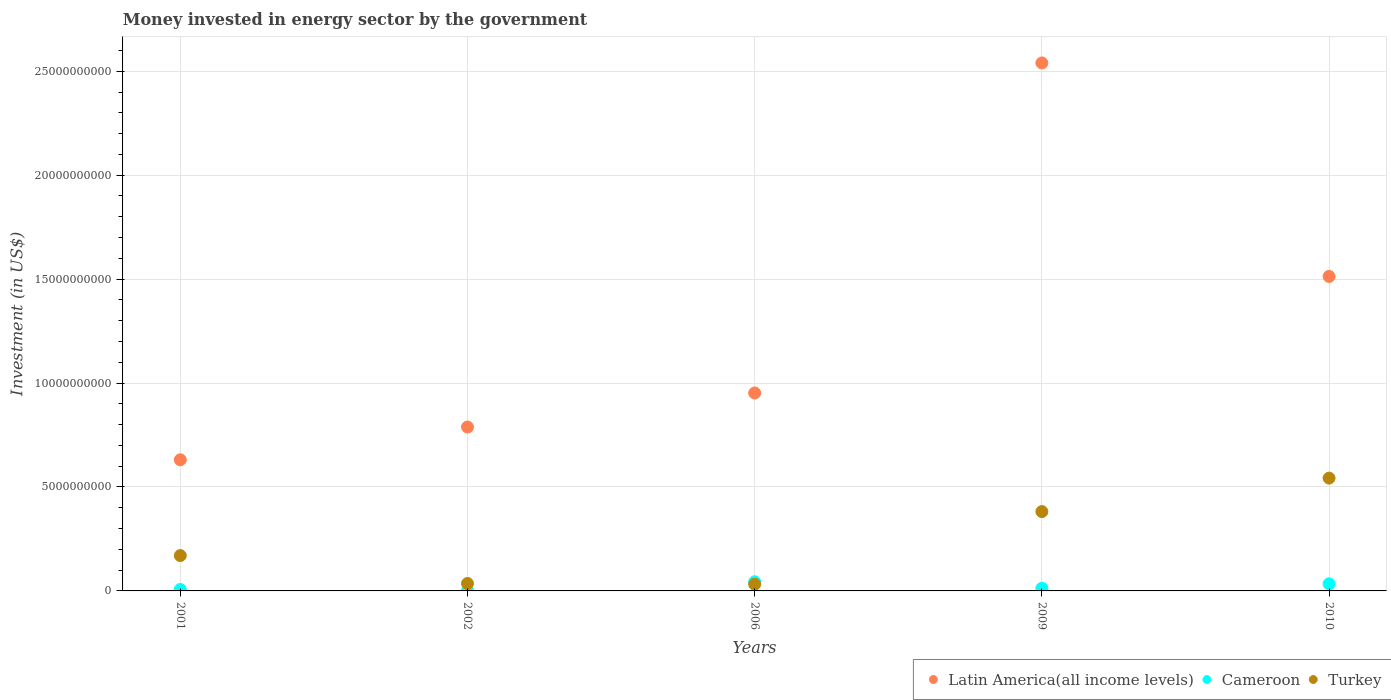What is the money spent in energy sector in Latin America(all income levels) in 2010?
Your answer should be compact. 1.51e+1. Across all years, what is the maximum money spent in energy sector in Cameroon?
Keep it short and to the point. 4.40e+08. Across all years, what is the minimum money spent in energy sector in Turkey?
Keep it short and to the point. 3.21e+08. In which year was the money spent in energy sector in Turkey maximum?
Keep it short and to the point. 2010. In which year was the money spent in energy sector in Latin America(all income levels) minimum?
Your response must be concise. 2001. What is the total money spent in energy sector in Latin America(all income levels) in the graph?
Offer a very short reply. 6.43e+1. What is the difference between the money spent in energy sector in Turkey in 2002 and that in 2010?
Give a very brief answer. -5.07e+09. What is the difference between the money spent in energy sector in Turkey in 2001 and the money spent in energy sector in Cameroon in 2009?
Ensure brevity in your answer.  1.57e+09. What is the average money spent in energy sector in Turkey per year?
Give a very brief answer. 2.32e+09. In the year 2009, what is the difference between the money spent in energy sector in Latin America(all income levels) and money spent in energy sector in Cameroon?
Your answer should be compact. 2.53e+1. What is the ratio of the money spent in energy sector in Latin America(all income levels) in 2009 to that in 2010?
Your answer should be very brief. 1.68. Is the money spent in energy sector in Latin America(all income levels) in 2001 less than that in 2010?
Offer a terse response. Yes. Is the difference between the money spent in energy sector in Latin America(all income levels) in 2009 and 2010 greater than the difference between the money spent in energy sector in Cameroon in 2009 and 2010?
Offer a terse response. Yes. What is the difference between the highest and the second highest money spent in energy sector in Turkey?
Ensure brevity in your answer.  1.61e+09. What is the difference between the highest and the lowest money spent in energy sector in Turkey?
Give a very brief answer. 5.11e+09. In how many years, is the money spent in energy sector in Cameroon greater than the average money spent in energy sector in Cameroon taken over all years?
Give a very brief answer. 2. Is the sum of the money spent in energy sector in Cameroon in 2001 and 2009 greater than the maximum money spent in energy sector in Turkey across all years?
Your response must be concise. No. How many dotlines are there?
Provide a succinct answer. 3. What is the difference between two consecutive major ticks on the Y-axis?
Give a very brief answer. 5.00e+09. Are the values on the major ticks of Y-axis written in scientific E-notation?
Make the answer very short. No. What is the title of the graph?
Give a very brief answer. Money invested in energy sector by the government. What is the label or title of the Y-axis?
Keep it short and to the point. Investment (in US$). What is the Investment (in US$) in Latin America(all income levels) in 2001?
Ensure brevity in your answer.  6.31e+09. What is the Investment (in US$) of Cameroon in 2001?
Keep it short and to the point. 7.03e+07. What is the Investment (in US$) of Turkey in 2001?
Offer a very short reply. 1.70e+09. What is the Investment (in US$) of Latin America(all income levels) in 2002?
Offer a very short reply. 7.89e+09. What is the Investment (in US$) of Cameroon in 2002?
Offer a very short reply. 2.15e+07. What is the Investment (in US$) of Turkey in 2002?
Make the answer very short. 3.60e+08. What is the Investment (in US$) of Latin America(all income levels) in 2006?
Offer a terse response. 9.52e+09. What is the Investment (in US$) of Cameroon in 2006?
Ensure brevity in your answer.  4.40e+08. What is the Investment (in US$) in Turkey in 2006?
Your answer should be compact. 3.21e+08. What is the Investment (in US$) of Latin America(all income levels) in 2009?
Make the answer very short. 2.54e+1. What is the Investment (in US$) in Cameroon in 2009?
Keep it short and to the point. 1.26e+08. What is the Investment (in US$) of Turkey in 2009?
Ensure brevity in your answer.  3.82e+09. What is the Investment (in US$) of Latin America(all income levels) in 2010?
Keep it short and to the point. 1.51e+1. What is the Investment (in US$) of Cameroon in 2010?
Your response must be concise. 3.42e+08. What is the Investment (in US$) in Turkey in 2010?
Your response must be concise. 5.43e+09. Across all years, what is the maximum Investment (in US$) of Latin America(all income levels)?
Ensure brevity in your answer.  2.54e+1. Across all years, what is the maximum Investment (in US$) of Cameroon?
Provide a succinct answer. 4.40e+08. Across all years, what is the maximum Investment (in US$) in Turkey?
Provide a short and direct response. 5.43e+09. Across all years, what is the minimum Investment (in US$) of Latin America(all income levels)?
Offer a very short reply. 6.31e+09. Across all years, what is the minimum Investment (in US$) of Cameroon?
Provide a succinct answer. 2.15e+07. Across all years, what is the minimum Investment (in US$) of Turkey?
Provide a succinct answer. 3.21e+08. What is the total Investment (in US$) of Latin America(all income levels) in the graph?
Make the answer very short. 6.43e+1. What is the total Investment (in US$) of Cameroon in the graph?
Ensure brevity in your answer.  1.00e+09. What is the total Investment (in US$) in Turkey in the graph?
Keep it short and to the point. 1.16e+1. What is the difference between the Investment (in US$) of Latin America(all income levels) in 2001 and that in 2002?
Your response must be concise. -1.58e+09. What is the difference between the Investment (in US$) in Cameroon in 2001 and that in 2002?
Give a very brief answer. 4.88e+07. What is the difference between the Investment (in US$) in Turkey in 2001 and that in 2002?
Your answer should be compact. 1.34e+09. What is the difference between the Investment (in US$) of Latin America(all income levels) in 2001 and that in 2006?
Offer a terse response. -3.21e+09. What is the difference between the Investment (in US$) of Cameroon in 2001 and that in 2006?
Offer a terse response. -3.70e+08. What is the difference between the Investment (in US$) of Turkey in 2001 and that in 2006?
Your answer should be very brief. 1.38e+09. What is the difference between the Investment (in US$) in Latin America(all income levels) in 2001 and that in 2009?
Offer a terse response. -1.91e+1. What is the difference between the Investment (in US$) of Cameroon in 2001 and that in 2009?
Your response must be concise. -5.57e+07. What is the difference between the Investment (in US$) in Turkey in 2001 and that in 2009?
Provide a succinct answer. -2.12e+09. What is the difference between the Investment (in US$) in Latin America(all income levels) in 2001 and that in 2010?
Provide a short and direct response. -8.82e+09. What is the difference between the Investment (in US$) of Cameroon in 2001 and that in 2010?
Your answer should be very brief. -2.72e+08. What is the difference between the Investment (in US$) in Turkey in 2001 and that in 2010?
Keep it short and to the point. -3.73e+09. What is the difference between the Investment (in US$) of Latin America(all income levels) in 2002 and that in 2006?
Your answer should be very brief. -1.64e+09. What is the difference between the Investment (in US$) in Cameroon in 2002 and that in 2006?
Provide a succinct answer. -4.18e+08. What is the difference between the Investment (in US$) of Turkey in 2002 and that in 2006?
Ensure brevity in your answer.  3.90e+07. What is the difference between the Investment (in US$) of Latin America(all income levels) in 2002 and that in 2009?
Give a very brief answer. -1.75e+1. What is the difference between the Investment (in US$) of Cameroon in 2002 and that in 2009?
Your answer should be very brief. -1.04e+08. What is the difference between the Investment (in US$) of Turkey in 2002 and that in 2009?
Offer a very short reply. -3.46e+09. What is the difference between the Investment (in US$) of Latin America(all income levels) in 2002 and that in 2010?
Provide a short and direct response. -7.24e+09. What is the difference between the Investment (in US$) of Cameroon in 2002 and that in 2010?
Your answer should be compact. -3.20e+08. What is the difference between the Investment (in US$) of Turkey in 2002 and that in 2010?
Your response must be concise. -5.07e+09. What is the difference between the Investment (in US$) in Latin America(all income levels) in 2006 and that in 2009?
Make the answer very short. -1.59e+1. What is the difference between the Investment (in US$) in Cameroon in 2006 and that in 2009?
Ensure brevity in your answer.  3.14e+08. What is the difference between the Investment (in US$) in Turkey in 2006 and that in 2009?
Your answer should be very brief. -3.50e+09. What is the difference between the Investment (in US$) of Latin America(all income levels) in 2006 and that in 2010?
Your response must be concise. -5.61e+09. What is the difference between the Investment (in US$) of Cameroon in 2006 and that in 2010?
Keep it short and to the point. 9.80e+07. What is the difference between the Investment (in US$) of Turkey in 2006 and that in 2010?
Offer a terse response. -5.11e+09. What is the difference between the Investment (in US$) of Latin America(all income levels) in 2009 and that in 2010?
Your answer should be compact. 1.03e+1. What is the difference between the Investment (in US$) of Cameroon in 2009 and that in 2010?
Give a very brief answer. -2.16e+08. What is the difference between the Investment (in US$) of Turkey in 2009 and that in 2010?
Offer a terse response. -1.61e+09. What is the difference between the Investment (in US$) of Latin America(all income levels) in 2001 and the Investment (in US$) of Cameroon in 2002?
Your answer should be compact. 6.29e+09. What is the difference between the Investment (in US$) of Latin America(all income levels) in 2001 and the Investment (in US$) of Turkey in 2002?
Your response must be concise. 5.95e+09. What is the difference between the Investment (in US$) of Cameroon in 2001 and the Investment (in US$) of Turkey in 2002?
Provide a short and direct response. -2.90e+08. What is the difference between the Investment (in US$) in Latin America(all income levels) in 2001 and the Investment (in US$) in Cameroon in 2006?
Offer a terse response. 5.87e+09. What is the difference between the Investment (in US$) in Latin America(all income levels) in 2001 and the Investment (in US$) in Turkey in 2006?
Make the answer very short. 5.99e+09. What is the difference between the Investment (in US$) of Cameroon in 2001 and the Investment (in US$) of Turkey in 2006?
Ensure brevity in your answer.  -2.51e+08. What is the difference between the Investment (in US$) in Latin America(all income levels) in 2001 and the Investment (in US$) in Cameroon in 2009?
Your answer should be very brief. 6.18e+09. What is the difference between the Investment (in US$) in Latin America(all income levels) in 2001 and the Investment (in US$) in Turkey in 2009?
Offer a terse response. 2.49e+09. What is the difference between the Investment (in US$) of Cameroon in 2001 and the Investment (in US$) of Turkey in 2009?
Offer a very short reply. -3.75e+09. What is the difference between the Investment (in US$) of Latin America(all income levels) in 2001 and the Investment (in US$) of Cameroon in 2010?
Provide a short and direct response. 5.97e+09. What is the difference between the Investment (in US$) of Latin America(all income levels) in 2001 and the Investment (in US$) of Turkey in 2010?
Offer a terse response. 8.83e+08. What is the difference between the Investment (in US$) in Cameroon in 2001 and the Investment (in US$) in Turkey in 2010?
Give a very brief answer. -5.36e+09. What is the difference between the Investment (in US$) in Latin America(all income levels) in 2002 and the Investment (in US$) in Cameroon in 2006?
Ensure brevity in your answer.  7.45e+09. What is the difference between the Investment (in US$) in Latin America(all income levels) in 2002 and the Investment (in US$) in Turkey in 2006?
Offer a very short reply. 7.56e+09. What is the difference between the Investment (in US$) of Cameroon in 2002 and the Investment (in US$) of Turkey in 2006?
Offer a terse response. -3.00e+08. What is the difference between the Investment (in US$) in Latin America(all income levels) in 2002 and the Investment (in US$) in Cameroon in 2009?
Provide a succinct answer. 7.76e+09. What is the difference between the Investment (in US$) in Latin America(all income levels) in 2002 and the Investment (in US$) in Turkey in 2009?
Offer a terse response. 4.07e+09. What is the difference between the Investment (in US$) of Cameroon in 2002 and the Investment (in US$) of Turkey in 2009?
Provide a short and direct response. -3.80e+09. What is the difference between the Investment (in US$) in Latin America(all income levels) in 2002 and the Investment (in US$) in Cameroon in 2010?
Ensure brevity in your answer.  7.54e+09. What is the difference between the Investment (in US$) in Latin America(all income levels) in 2002 and the Investment (in US$) in Turkey in 2010?
Offer a terse response. 2.46e+09. What is the difference between the Investment (in US$) of Cameroon in 2002 and the Investment (in US$) of Turkey in 2010?
Keep it short and to the point. -5.41e+09. What is the difference between the Investment (in US$) of Latin America(all income levels) in 2006 and the Investment (in US$) of Cameroon in 2009?
Offer a very short reply. 9.40e+09. What is the difference between the Investment (in US$) of Latin America(all income levels) in 2006 and the Investment (in US$) of Turkey in 2009?
Offer a very short reply. 5.71e+09. What is the difference between the Investment (in US$) in Cameroon in 2006 and the Investment (in US$) in Turkey in 2009?
Offer a very short reply. -3.38e+09. What is the difference between the Investment (in US$) of Latin America(all income levels) in 2006 and the Investment (in US$) of Cameroon in 2010?
Offer a terse response. 9.18e+09. What is the difference between the Investment (in US$) of Latin America(all income levels) in 2006 and the Investment (in US$) of Turkey in 2010?
Give a very brief answer. 4.10e+09. What is the difference between the Investment (in US$) in Cameroon in 2006 and the Investment (in US$) in Turkey in 2010?
Provide a succinct answer. -4.99e+09. What is the difference between the Investment (in US$) of Latin America(all income levels) in 2009 and the Investment (in US$) of Cameroon in 2010?
Your response must be concise. 2.51e+1. What is the difference between the Investment (in US$) of Latin America(all income levels) in 2009 and the Investment (in US$) of Turkey in 2010?
Offer a terse response. 2.00e+1. What is the difference between the Investment (in US$) of Cameroon in 2009 and the Investment (in US$) of Turkey in 2010?
Provide a short and direct response. -5.30e+09. What is the average Investment (in US$) of Latin America(all income levels) per year?
Keep it short and to the point. 1.29e+1. What is the average Investment (in US$) in Cameroon per year?
Give a very brief answer. 2.00e+08. What is the average Investment (in US$) in Turkey per year?
Provide a short and direct response. 2.32e+09. In the year 2001, what is the difference between the Investment (in US$) of Latin America(all income levels) and Investment (in US$) of Cameroon?
Your response must be concise. 6.24e+09. In the year 2001, what is the difference between the Investment (in US$) in Latin America(all income levels) and Investment (in US$) in Turkey?
Your answer should be very brief. 4.61e+09. In the year 2001, what is the difference between the Investment (in US$) of Cameroon and Investment (in US$) of Turkey?
Offer a very short reply. -1.63e+09. In the year 2002, what is the difference between the Investment (in US$) of Latin America(all income levels) and Investment (in US$) of Cameroon?
Provide a succinct answer. 7.86e+09. In the year 2002, what is the difference between the Investment (in US$) of Latin America(all income levels) and Investment (in US$) of Turkey?
Keep it short and to the point. 7.53e+09. In the year 2002, what is the difference between the Investment (in US$) in Cameroon and Investment (in US$) in Turkey?
Your response must be concise. -3.38e+08. In the year 2006, what is the difference between the Investment (in US$) in Latin America(all income levels) and Investment (in US$) in Cameroon?
Keep it short and to the point. 9.08e+09. In the year 2006, what is the difference between the Investment (in US$) in Latin America(all income levels) and Investment (in US$) in Turkey?
Offer a very short reply. 9.20e+09. In the year 2006, what is the difference between the Investment (in US$) of Cameroon and Investment (in US$) of Turkey?
Your answer should be very brief. 1.19e+08. In the year 2009, what is the difference between the Investment (in US$) of Latin America(all income levels) and Investment (in US$) of Cameroon?
Make the answer very short. 2.53e+1. In the year 2009, what is the difference between the Investment (in US$) in Latin America(all income levels) and Investment (in US$) in Turkey?
Your answer should be very brief. 2.16e+1. In the year 2009, what is the difference between the Investment (in US$) in Cameroon and Investment (in US$) in Turkey?
Ensure brevity in your answer.  -3.69e+09. In the year 2010, what is the difference between the Investment (in US$) in Latin America(all income levels) and Investment (in US$) in Cameroon?
Give a very brief answer. 1.48e+1. In the year 2010, what is the difference between the Investment (in US$) in Latin America(all income levels) and Investment (in US$) in Turkey?
Make the answer very short. 9.70e+09. In the year 2010, what is the difference between the Investment (in US$) in Cameroon and Investment (in US$) in Turkey?
Your response must be concise. -5.09e+09. What is the ratio of the Investment (in US$) of Latin America(all income levels) in 2001 to that in 2002?
Offer a terse response. 0.8. What is the ratio of the Investment (in US$) in Cameroon in 2001 to that in 2002?
Keep it short and to the point. 3.27. What is the ratio of the Investment (in US$) of Turkey in 2001 to that in 2002?
Keep it short and to the point. 4.72. What is the ratio of the Investment (in US$) in Latin America(all income levels) in 2001 to that in 2006?
Ensure brevity in your answer.  0.66. What is the ratio of the Investment (in US$) of Cameroon in 2001 to that in 2006?
Offer a terse response. 0.16. What is the ratio of the Investment (in US$) in Turkey in 2001 to that in 2006?
Provide a short and direct response. 5.3. What is the ratio of the Investment (in US$) of Latin America(all income levels) in 2001 to that in 2009?
Keep it short and to the point. 0.25. What is the ratio of the Investment (in US$) of Cameroon in 2001 to that in 2009?
Provide a succinct answer. 0.56. What is the ratio of the Investment (in US$) in Turkey in 2001 to that in 2009?
Your answer should be very brief. 0.45. What is the ratio of the Investment (in US$) of Latin America(all income levels) in 2001 to that in 2010?
Your answer should be compact. 0.42. What is the ratio of the Investment (in US$) of Cameroon in 2001 to that in 2010?
Provide a short and direct response. 0.21. What is the ratio of the Investment (in US$) of Turkey in 2001 to that in 2010?
Offer a very short reply. 0.31. What is the ratio of the Investment (in US$) of Latin America(all income levels) in 2002 to that in 2006?
Your response must be concise. 0.83. What is the ratio of the Investment (in US$) in Cameroon in 2002 to that in 2006?
Your response must be concise. 0.05. What is the ratio of the Investment (in US$) of Turkey in 2002 to that in 2006?
Your answer should be very brief. 1.12. What is the ratio of the Investment (in US$) in Latin America(all income levels) in 2002 to that in 2009?
Your answer should be very brief. 0.31. What is the ratio of the Investment (in US$) in Cameroon in 2002 to that in 2009?
Your answer should be compact. 0.17. What is the ratio of the Investment (in US$) of Turkey in 2002 to that in 2009?
Offer a terse response. 0.09. What is the ratio of the Investment (in US$) of Latin America(all income levels) in 2002 to that in 2010?
Provide a succinct answer. 0.52. What is the ratio of the Investment (in US$) in Cameroon in 2002 to that in 2010?
Your answer should be very brief. 0.06. What is the ratio of the Investment (in US$) of Turkey in 2002 to that in 2010?
Make the answer very short. 0.07. What is the ratio of the Investment (in US$) of Latin America(all income levels) in 2006 to that in 2009?
Offer a very short reply. 0.37. What is the ratio of the Investment (in US$) of Cameroon in 2006 to that in 2009?
Provide a short and direct response. 3.49. What is the ratio of the Investment (in US$) in Turkey in 2006 to that in 2009?
Keep it short and to the point. 0.08. What is the ratio of the Investment (in US$) of Latin America(all income levels) in 2006 to that in 2010?
Make the answer very short. 0.63. What is the ratio of the Investment (in US$) of Cameroon in 2006 to that in 2010?
Give a very brief answer. 1.29. What is the ratio of the Investment (in US$) of Turkey in 2006 to that in 2010?
Offer a terse response. 0.06. What is the ratio of the Investment (in US$) of Latin America(all income levels) in 2009 to that in 2010?
Keep it short and to the point. 1.68. What is the ratio of the Investment (in US$) in Cameroon in 2009 to that in 2010?
Provide a short and direct response. 0.37. What is the ratio of the Investment (in US$) of Turkey in 2009 to that in 2010?
Keep it short and to the point. 0.7. What is the difference between the highest and the second highest Investment (in US$) in Latin America(all income levels)?
Offer a terse response. 1.03e+1. What is the difference between the highest and the second highest Investment (in US$) in Cameroon?
Your response must be concise. 9.80e+07. What is the difference between the highest and the second highest Investment (in US$) in Turkey?
Ensure brevity in your answer.  1.61e+09. What is the difference between the highest and the lowest Investment (in US$) of Latin America(all income levels)?
Provide a succinct answer. 1.91e+1. What is the difference between the highest and the lowest Investment (in US$) in Cameroon?
Make the answer very short. 4.18e+08. What is the difference between the highest and the lowest Investment (in US$) in Turkey?
Keep it short and to the point. 5.11e+09. 